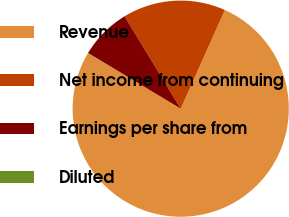<chart> <loc_0><loc_0><loc_500><loc_500><pie_chart><fcel>Revenue<fcel>Net income from continuing<fcel>Earnings per share from<fcel>Diluted<nl><fcel>76.89%<fcel>15.39%<fcel>7.7%<fcel>0.02%<nl></chart> 